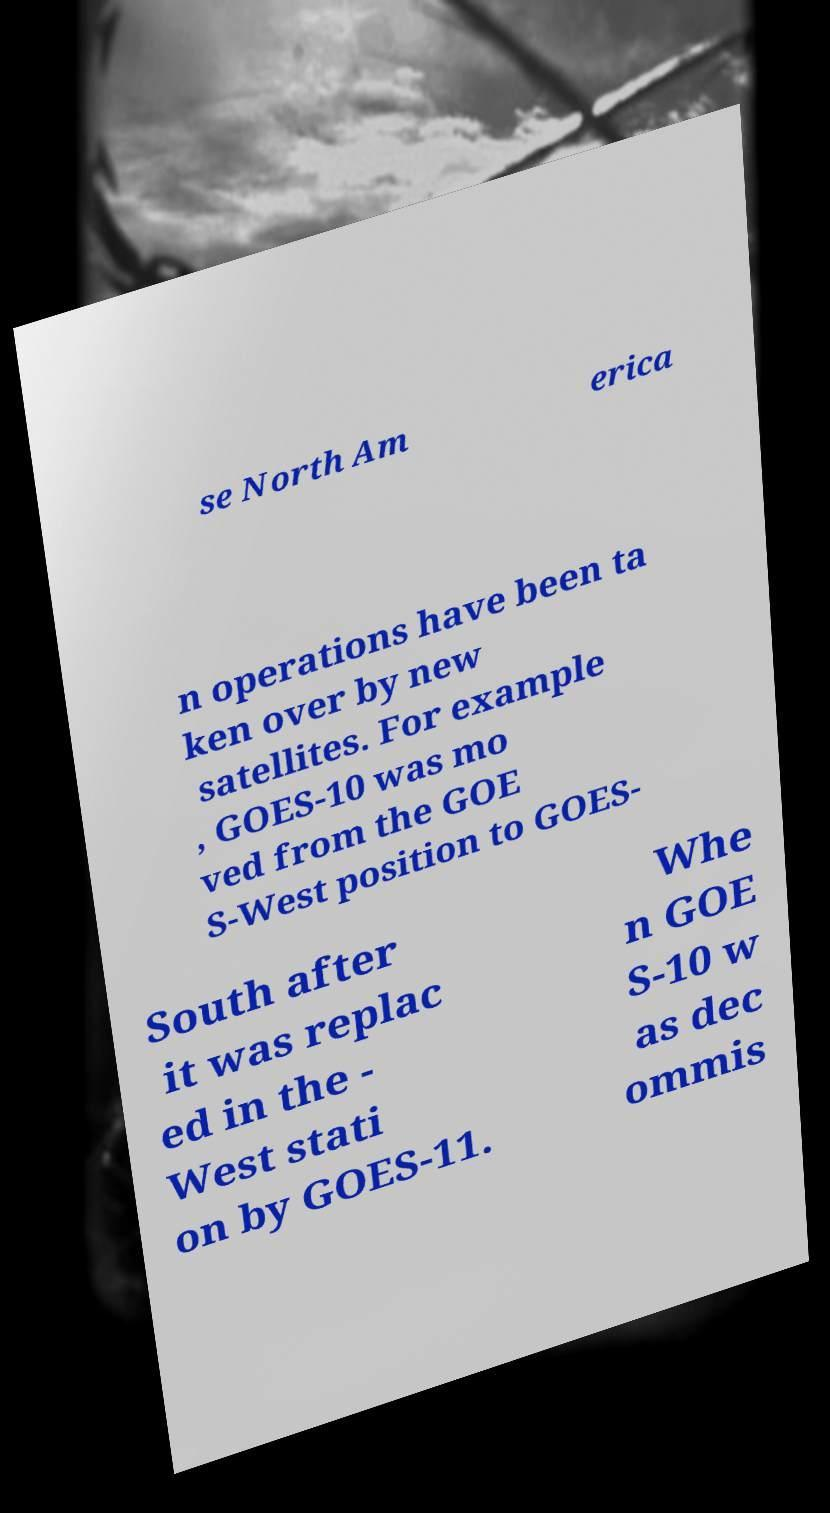Can you read and provide the text displayed in the image?This photo seems to have some interesting text. Can you extract and type it out for me? se North Am erica n operations have been ta ken over by new satellites. For example , GOES-10 was mo ved from the GOE S-West position to GOES- South after it was replac ed in the - West stati on by GOES-11. Whe n GOE S-10 w as dec ommis 